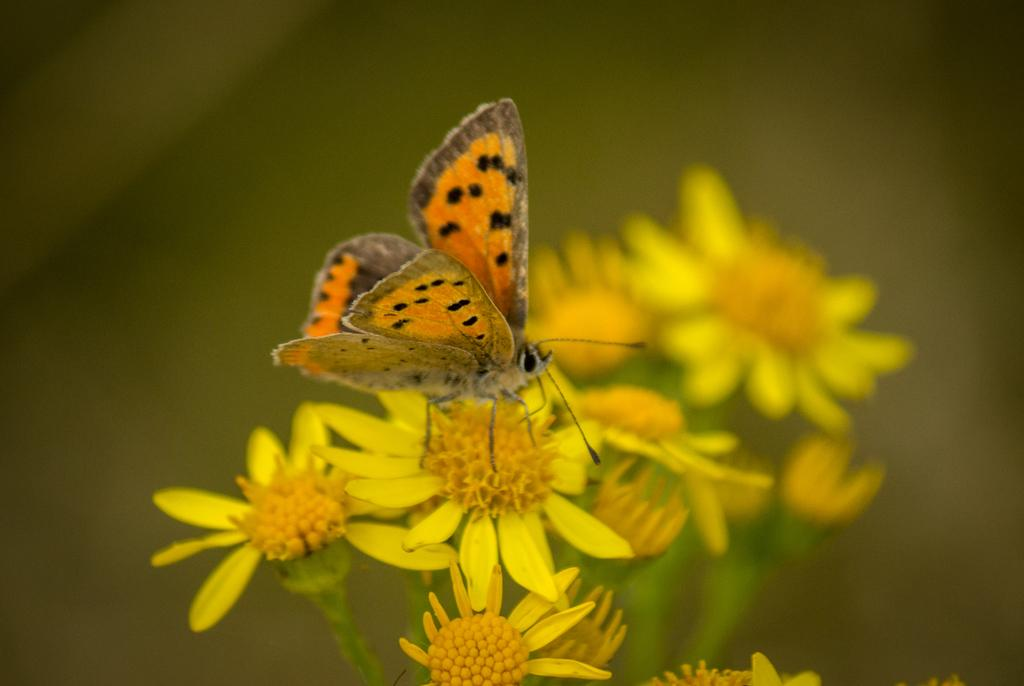What type of insect is present in the image? There is a butterfly in the image. What other living organisms can be seen in the image? There are flowers in the image. Can you describe the background of the image? The background of the image is blurred. What direction is the butterfly flying in the image? The direction in which the butterfly is flying cannot be determined from the image, as it is not moving. 